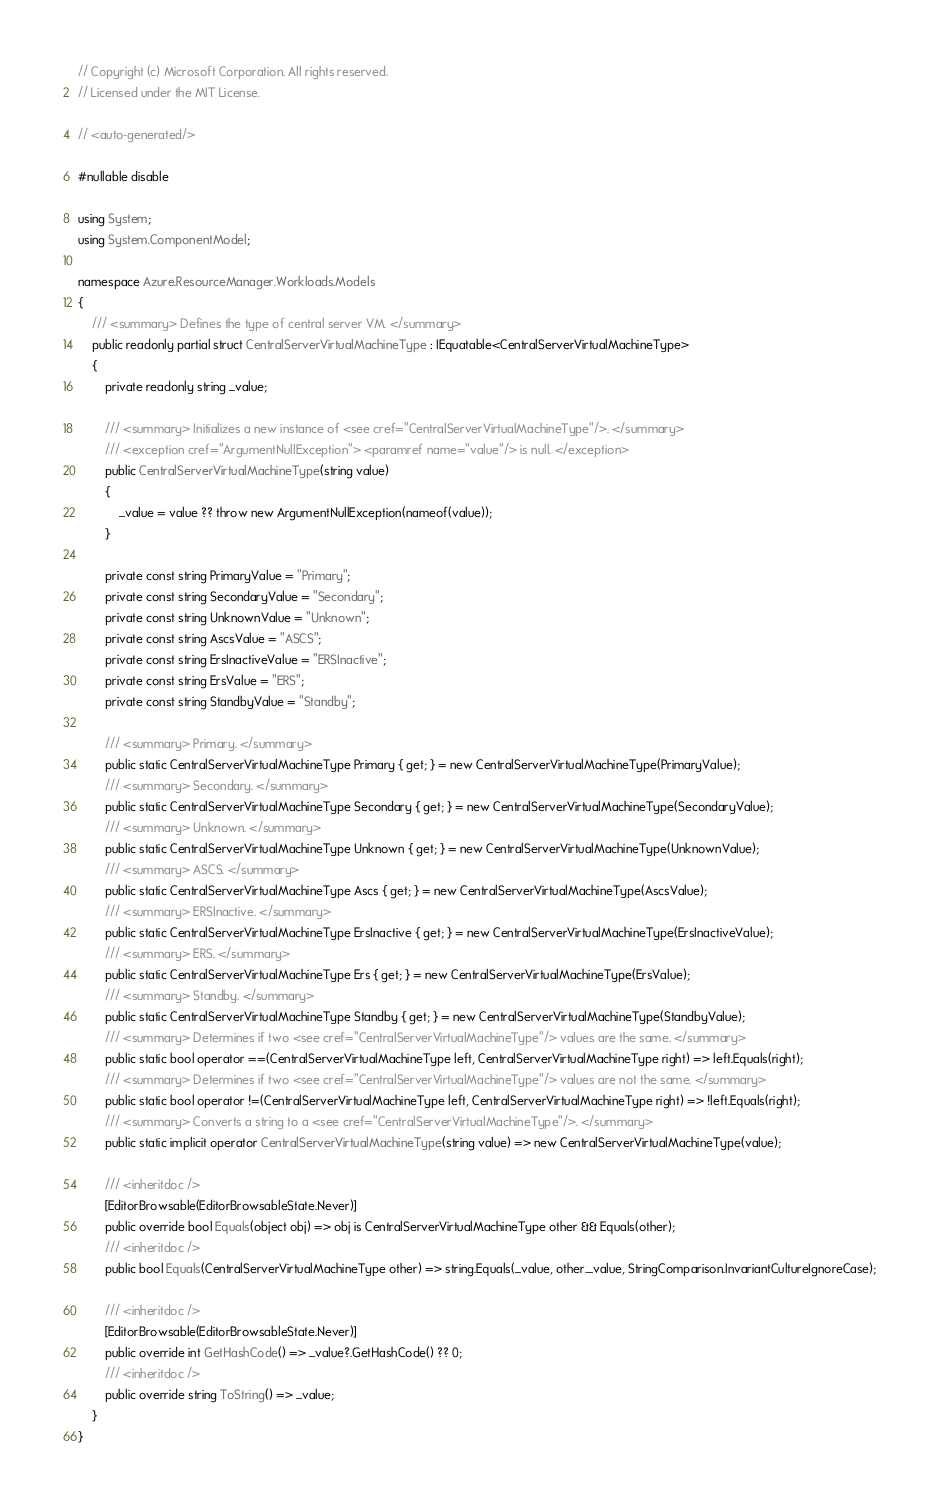<code> <loc_0><loc_0><loc_500><loc_500><_C#_>// Copyright (c) Microsoft Corporation. All rights reserved.
// Licensed under the MIT License.

// <auto-generated/>

#nullable disable

using System;
using System.ComponentModel;

namespace Azure.ResourceManager.Workloads.Models
{
    /// <summary> Defines the type of central server VM. </summary>
    public readonly partial struct CentralServerVirtualMachineType : IEquatable<CentralServerVirtualMachineType>
    {
        private readonly string _value;

        /// <summary> Initializes a new instance of <see cref="CentralServerVirtualMachineType"/>. </summary>
        /// <exception cref="ArgumentNullException"> <paramref name="value"/> is null. </exception>
        public CentralServerVirtualMachineType(string value)
        {
            _value = value ?? throw new ArgumentNullException(nameof(value));
        }

        private const string PrimaryValue = "Primary";
        private const string SecondaryValue = "Secondary";
        private const string UnknownValue = "Unknown";
        private const string AscsValue = "ASCS";
        private const string ErsInactiveValue = "ERSInactive";
        private const string ErsValue = "ERS";
        private const string StandbyValue = "Standby";

        /// <summary> Primary. </summary>
        public static CentralServerVirtualMachineType Primary { get; } = new CentralServerVirtualMachineType(PrimaryValue);
        /// <summary> Secondary. </summary>
        public static CentralServerVirtualMachineType Secondary { get; } = new CentralServerVirtualMachineType(SecondaryValue);
        /// <summary> Unknown. </summary>
        public static CentralServerVirtualMachineType Unknown { get; } = new CentralServerVirtualMachineType(UnknownValue);
        /// <summary> ASCS. </summary>
        public static CentralServerVirtualMachineType Ascs { get; } = new CentralServerVirtualMachineType(AscsValue);
        /// <summary> ERSInactive. </summary>
        public static CentralServerVirtualMachineType ErsInactive { get; } = new CentralServerVirtualMachineType(ErsInactiveValue);
        /// <summary> ERS. </summary>
        public static CentralServerVirtualMachineType Ers { get; } = new CentralServerVirtualMachineType(ErsValue);
        /// <summary> Standby. </summary>
        public static CentralServerVirtualMachineType Standby { get; } = new CentralServerVirtualMachineType(StandbyValue);
        /// <summary> Determines if two <see cref="CentralServerVirtualMachineType"/> values are the same. </summary>
        public static bool operator ==(CentralServerVirtualMachineType left, CentralServerVirtualMachineType right) => left.Equals(right);
        /// <summary> Determines if two <see cref="CentralServerVirtualMachineType"/> values are not the same. </summary>
        public static bool operator !=(CentralServerVirtualMachineType left, CentralServerVirtualMachineType right) => !left.Equals(right);
        /// <summary> Converts a string to a <see cref="CentralServerVirtualMachineType"/>. </summary>
        public static implicit operator CentralServerVirtualMachineType(string value) => new CentralServerVirtualMachineType(value);

        /// <inheritdoc />
        [EditorBrowsable(EditorBrowsableState.Never)]
        public override bool Equals(object obj) => obj is CentralServerVirtualMachineType other && Equals(other);
        /// <inheritdoc />
        public bool Equals(CentralServerVirtualMachineType other) => string.Equals(_value, other._value, StringComparison.InvariantCultureIgnoreCase);

        /// <inheritdoc />
        [EditorBrowsable(EditorBrowsableState.Never)]
        public override int GetHashCode() => _value?.GetHashCode() ?? 0;
        /// <inheritdoc />
        public override string ToString() => _value;
    }
}
</code> 